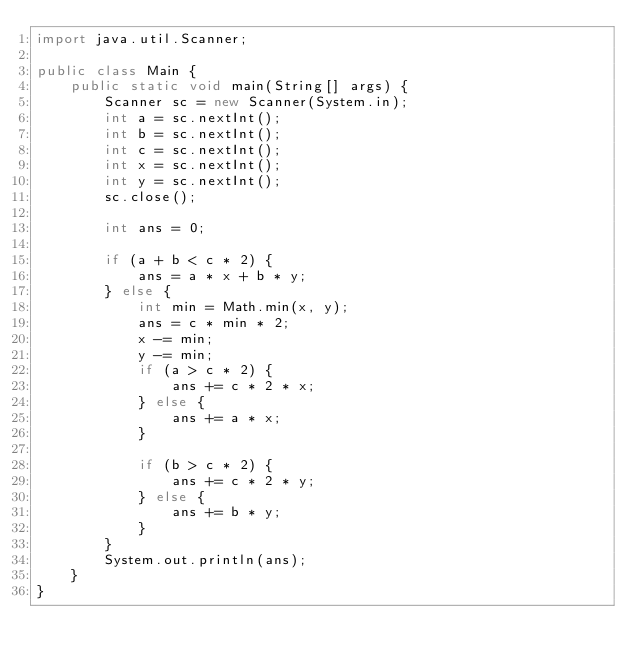<code> <loc_0><loc_0><loc_500><loc_500><_Java_>import java.util.Scanner;

public class Main {
    public static void main(String[] args) {
        Scanner sc = new Scanner(System.in);
        int a = sc.nextInt();
        int b = sc.nextInt();
        int c = sc.nextInt();
        int x = sc.nextInt();
        int y = sc.nextInt();
        sc.close();

        int ans = 0;

        if (a + b < c * 2) {
            ans = a * x + b * y;
        } else {
            int min = Math.min(x, y);
            ans = c * min * 2;
            x -= min;
            y -= min;
            if (a > c * 2) {
                ans += c * 2 * x;
            } else {
                ans += a * x;
            }

            if (b > c * 2) {
                ans += c * 2 * y;
            } else {
                ans += b * y;
            }
        }
        System.out.println(ans);
    }
}</code> 